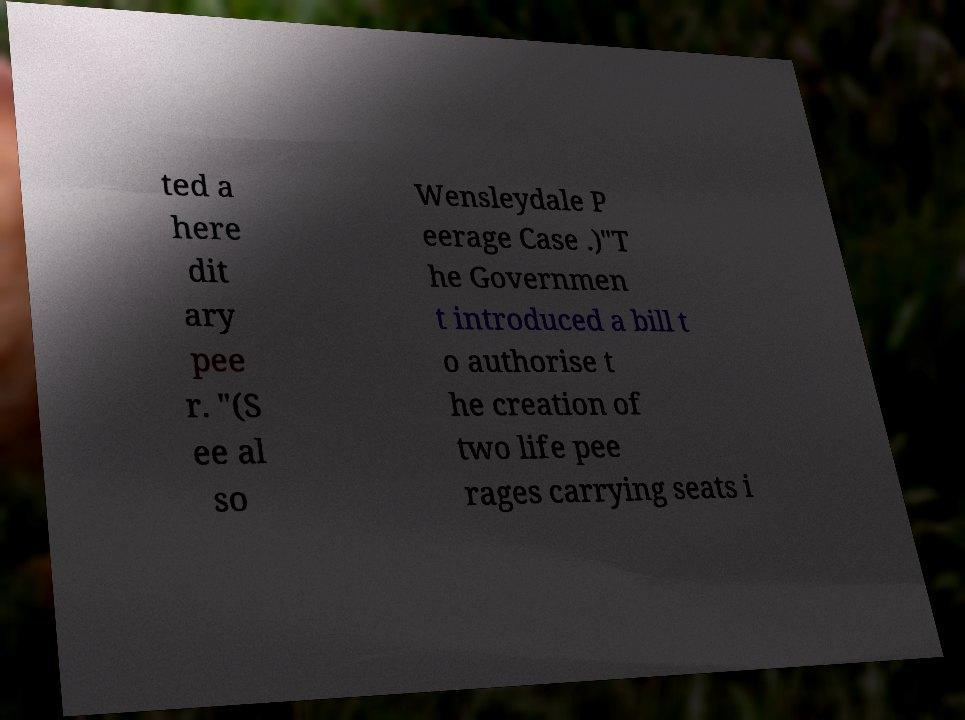What messages or text are displayed in this image? I need them in a readable, typed format. ted a here dit ary pee r. "(S ee al so Wensleydale P eerage Case .)"T he Governmen t introduced a bill t o authorise t he creation of two life pee rages carrying seats i 